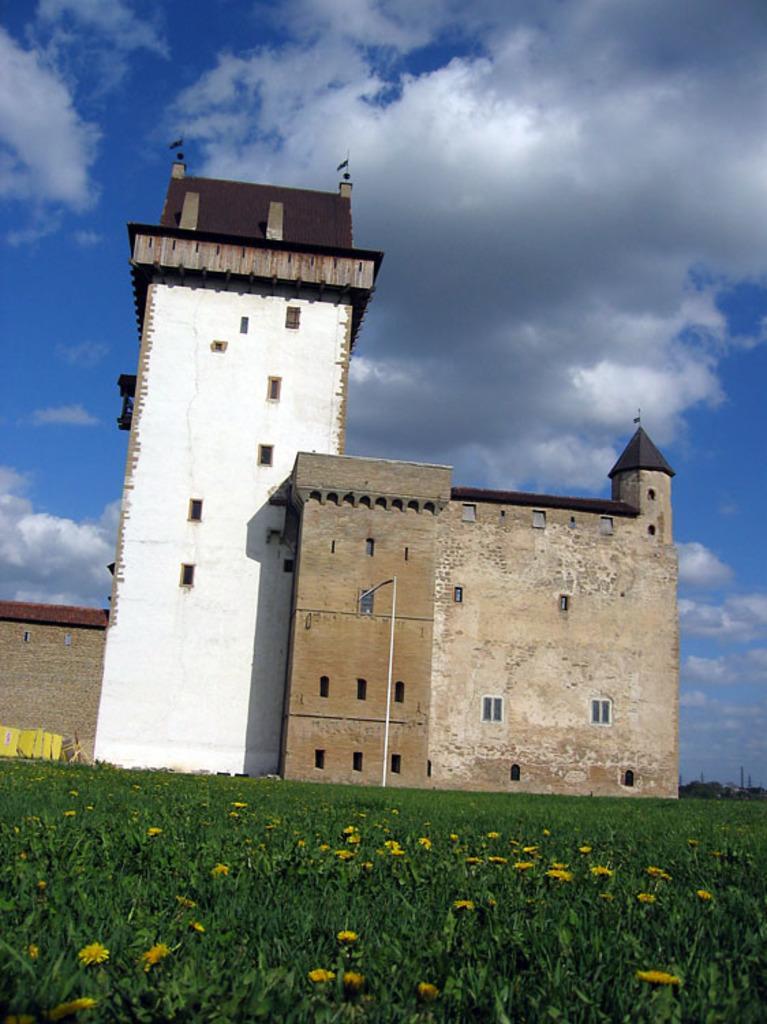In one or two sentences, can you explain what this image depicts? In the picture I can see a building, flower plants and flags on the building. In the background I can see the sky. 